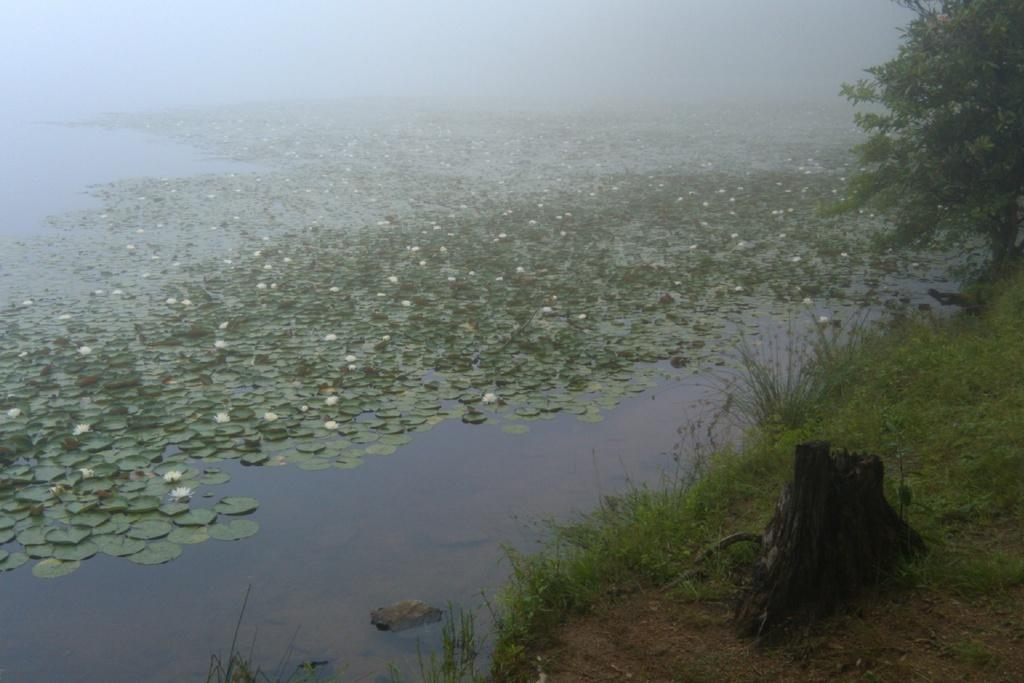What type of flowers are in the image? There are lotus flowers in the image. What else can be seen in the image besides the lotus flowers? There are leaves in the image. Where are the lotus flowers and leaves located? The lotus flowers and leaves are in a pond. What can be seen in the right bottom corner of the image? There are trees and grass in the right bottom corner of the image. How many crackers are floating on the surface of the pond in the image? There are no crackers present in the image; it features lotus flowers and leaves in a pond. What type of property can be seen in the image? There is no property visible in the image; it features a pond with lotus flowers and leaves, trees, and grass. 